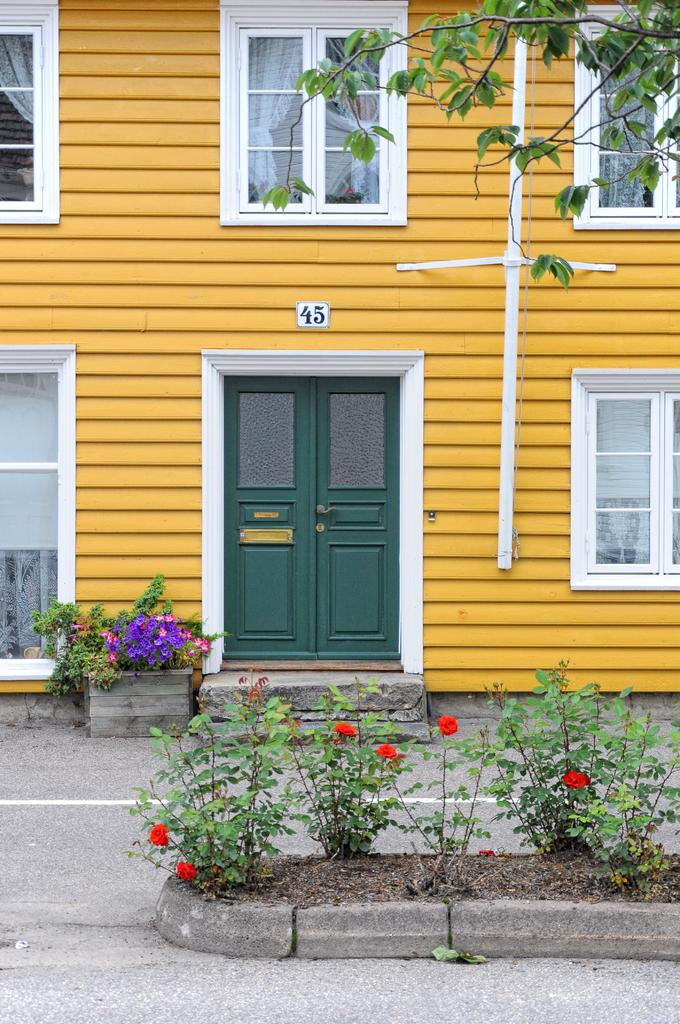What is the main structure in the center of the image? There is a house in the center of the image. What features does the house have? The house has a door and windows. What can be seen in the image besides the house? There are plants and a flower pot in the image. What is located at the bottom of the image? There is a road at the bottom of the image. What type of hair can be seen on the plants in the image? There is no hair present on the plants in the image; they are plants, not animals with hair. 